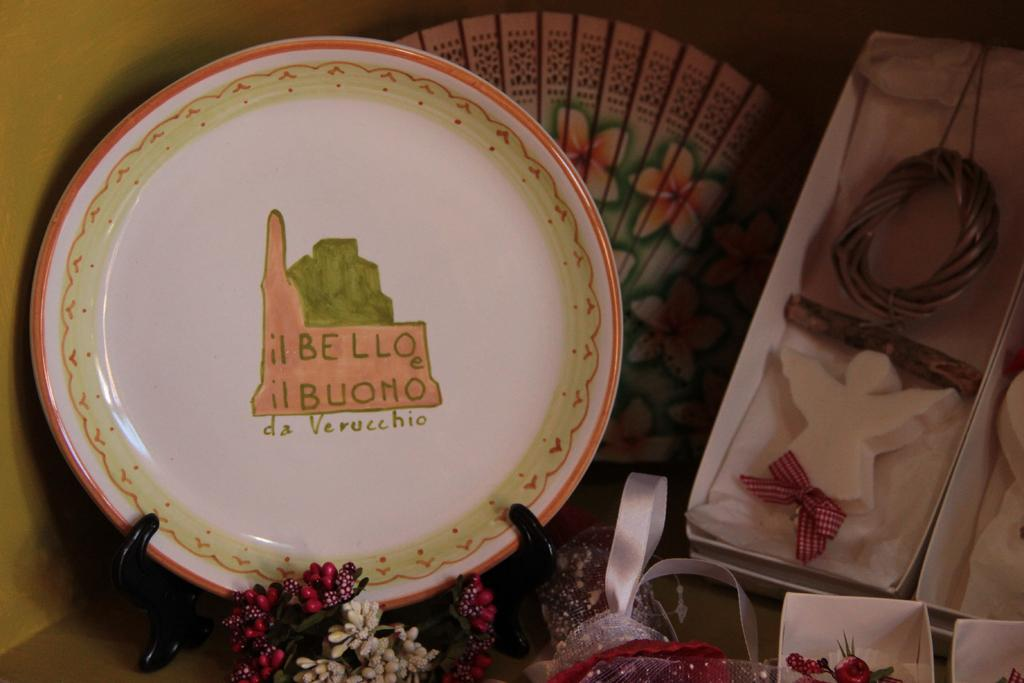What is on the plate that is visible in the image? There is text and a painting on a plate in the image. What type of decorative items can be seen in the image? There are decorative items in the image. What is visible in the background of the image? There is a wall visible in the image. What type of stocking is hanging on the wall in the image? There is no stocking hanging on the wall in the image. What type of border is visible around the painting on the plate? The provided facts do not mention a border around the painting on the plate. 